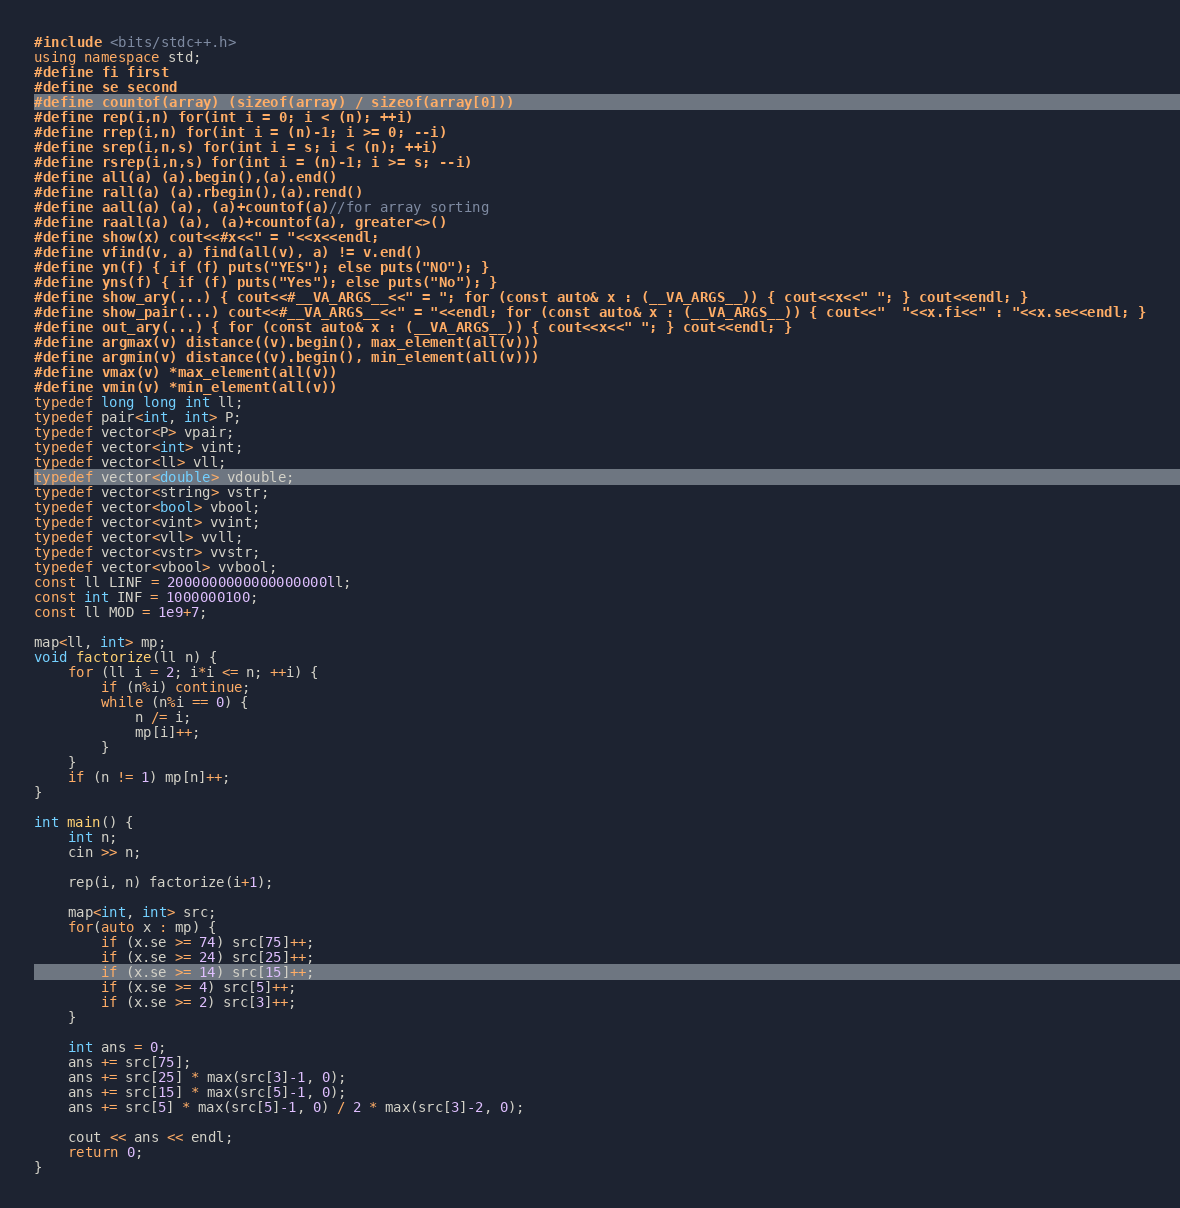Convert code to text. <code><loc_0><loc_0><loc_500><loc_500><_C++_>#include <bits/stdc++.h>
using namespace std;
#define fi first
#define se second
#define countof(array) (sizeof(array) / sizeof(array[0]))
#define rep(i,n) for(int i = 0; i < (n); ++i)
#define rrep(i,n) for(int i = (n)-1; i >= 0; --i)
#define srep(i,n,s) for(int i = s; i < (n); ++i)
#define rsrep(i,n,s) for(int i = (n)-1; i >= s; --i)
#define all(a) (a).begin(),(a).end()
#define rall(a) (a).rbegin(),(a).rend()
#define aall(a) (a), (a)+countof(a)//for array sorting
#define raall(a) (a), (a)+countof(a), greater<>()
#define show(x) cout<<#x<<" = "<<x<<endl;
#define vfind(v, a) find(all(v), a) != v.end()
#define yn(f) { if (f) puts("YES"); else puts("NO"); }
#define yns(f) { if (f) puts("Yes"); else puts("No"); }
#define show_ary(...) { cout<<#__VA_ARGS__<<" = "; for (const auto& x : (__VA_ARGS__)) { cout<<x<<" "; } cout<<endl; }
#define show_pair(...) cout<<#__VA_ARGS__<<" = "<<endl; for (const auto& x : (__VA_ARGS__)) { cout<<"  "<<x.fi<<" : "<<x.se<<endl; }
#define out_ary(...) { for (const auto& x : (__VA_ARGS__)) { cout<<x<<" "; } cout<<endl; }
#define argmax(v) distance((v).begin(), max_element(all(v)))
#define argmin(v) distance((v).begin(), min_element(all(v)))
#define vmax(v) *max_element(all(v))
#define vmin(v) *min_element(all(v))
typedef long long int ll;
typedef pair<int, int> P;
typedef vector<P> vpair;
typedef vector<int> vint;
typedef vector<ll> vll;
typedef vector<double> vdouble;
typedef vector<string> vstr;
typedef vector<bool> vbool;
typedef vector<vint> vvint;
typedef vector<vll> vvll;
typedef vector<vstr> vvstr;
typedef vector<vbool> vvbool;
const ll LINF = 2000000000000000000ll;
const int INF = 1000000100;
const ll MOD = 1e9+7;

map<ll, int> mp;
void factorize(ll n) {
    for (ll i = 2; i*i <= n; ++i) {
        if (n%i) continue;
        while (n%i == 0) {
            n /= i;
            mp[i]++;
        }
    }
    if (n != 1) mp[n]++;
}

int main() {
    int n;
    cin >> n;

    rep(i, n) factorize(i+1);

    map<int, int> src;
    for(auto x : mp) {
        if (x.se >= 74) src[75]++;
        if (x.se >= 24) src[25]++;
        if (x.se >= 14) src[15]++;
        if (x.se >= 4) src[5]++;
        if (x.se >= 2) src[3]++;
    }

    int ans = 0;
    ans += src[75];
    ans += src[25] * max(src[3]-1, 0);
    ans += src[15] * max(src[5]-1, 0);
    ans += src[5] * max(src[5]-1, 0) / 2 * max(src[3]-2, 0);    

    cout << ans << endl;
    return 0;
}</code> 